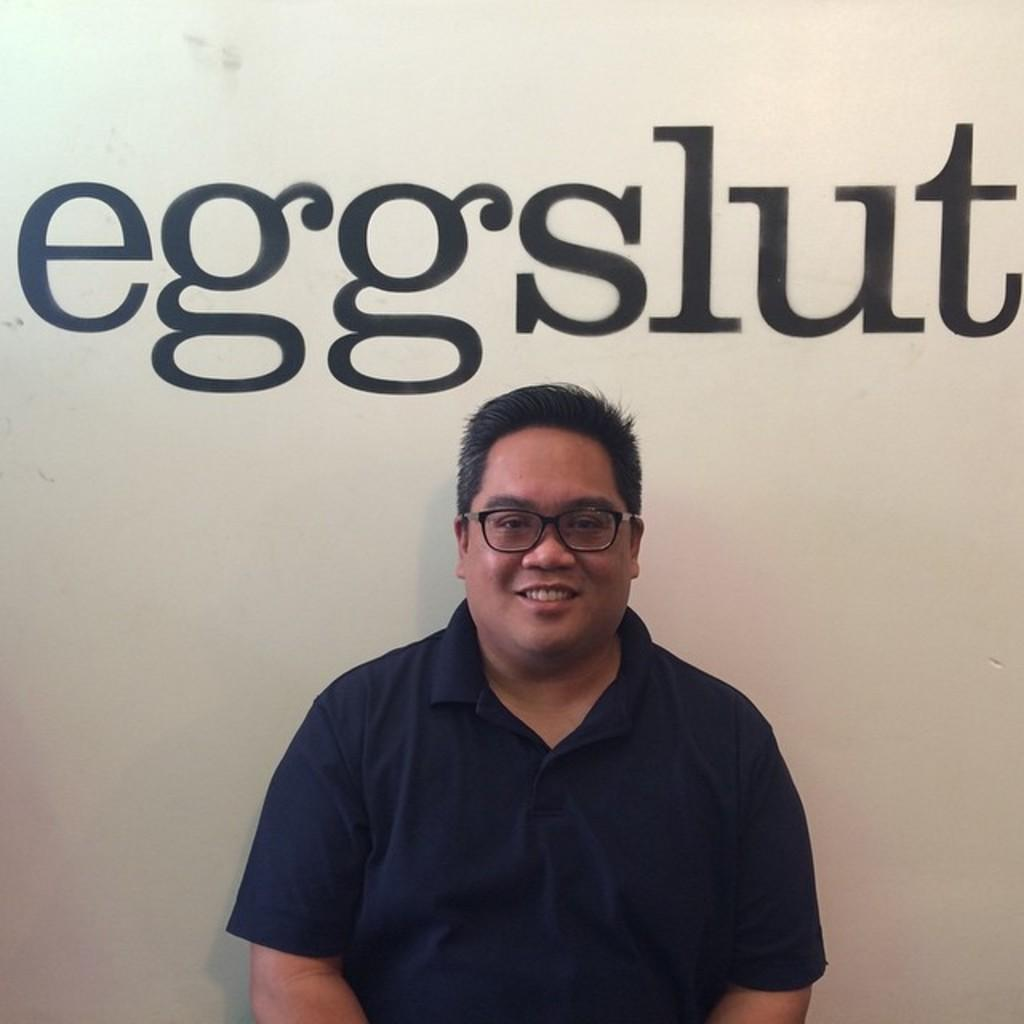Who is present in the image? There is a man in the image. What is the man doing in the image? The man is sitting in the image. What is the man's facial expression in the image? The man is smiling in the image. What can be seen in the background of the image? There is a wall in the background of the image. What is written or depicted on the wall in the background? There is text on the wall in the background. What type of bridge can be seen in the image? There is no bridge present in the image. What route is the actor taking in the image? There is no actor or route present in the image. 